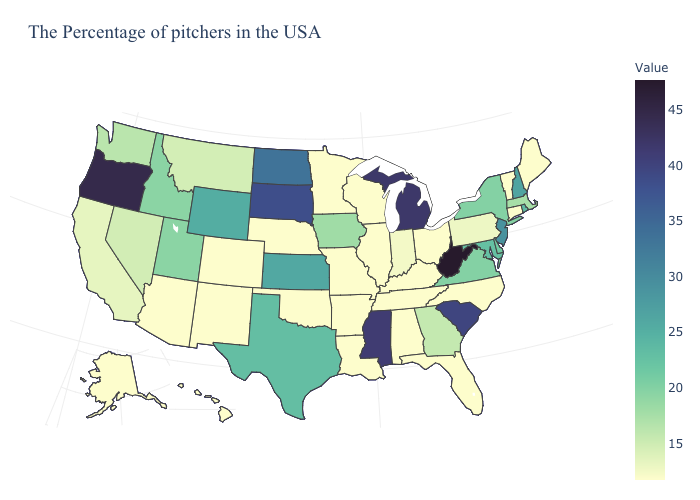Among the states that border California , does Oregon have the lowest value?
Give a very brief answer. No. Does Wyoming have a higher value than New Mexico?
Concise answer only. Yes. Does West Virginia have the highest value in the South?
Concise answer only. Yes. Does West Virginia have the highest value in the South?
Keep it brief. Yes. Among the states that border South Dakota , which have the highest value?
Quick response, please. North Dakota. 